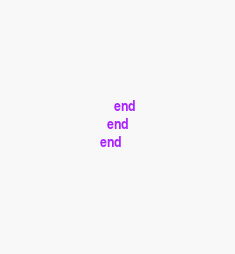<code> <loc_0><loc_0><loc_500><loc_500><_Ruby_>    end
  end
end
</code> 